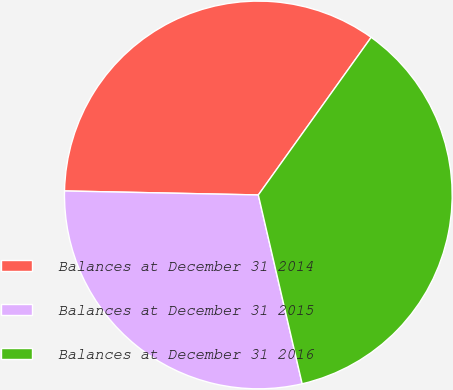Convert chart to OTSL. <chart><loc_0><loc_0><loc_500><loc_500><pie_chart><fcel>Balances at December 31 2014<fcel>Balances at December 31 2015<fcel>Balances at December 31 2016<nl><fcel>34.56%<fcel>28.96%<fcel>36.48%<nl></chart> 